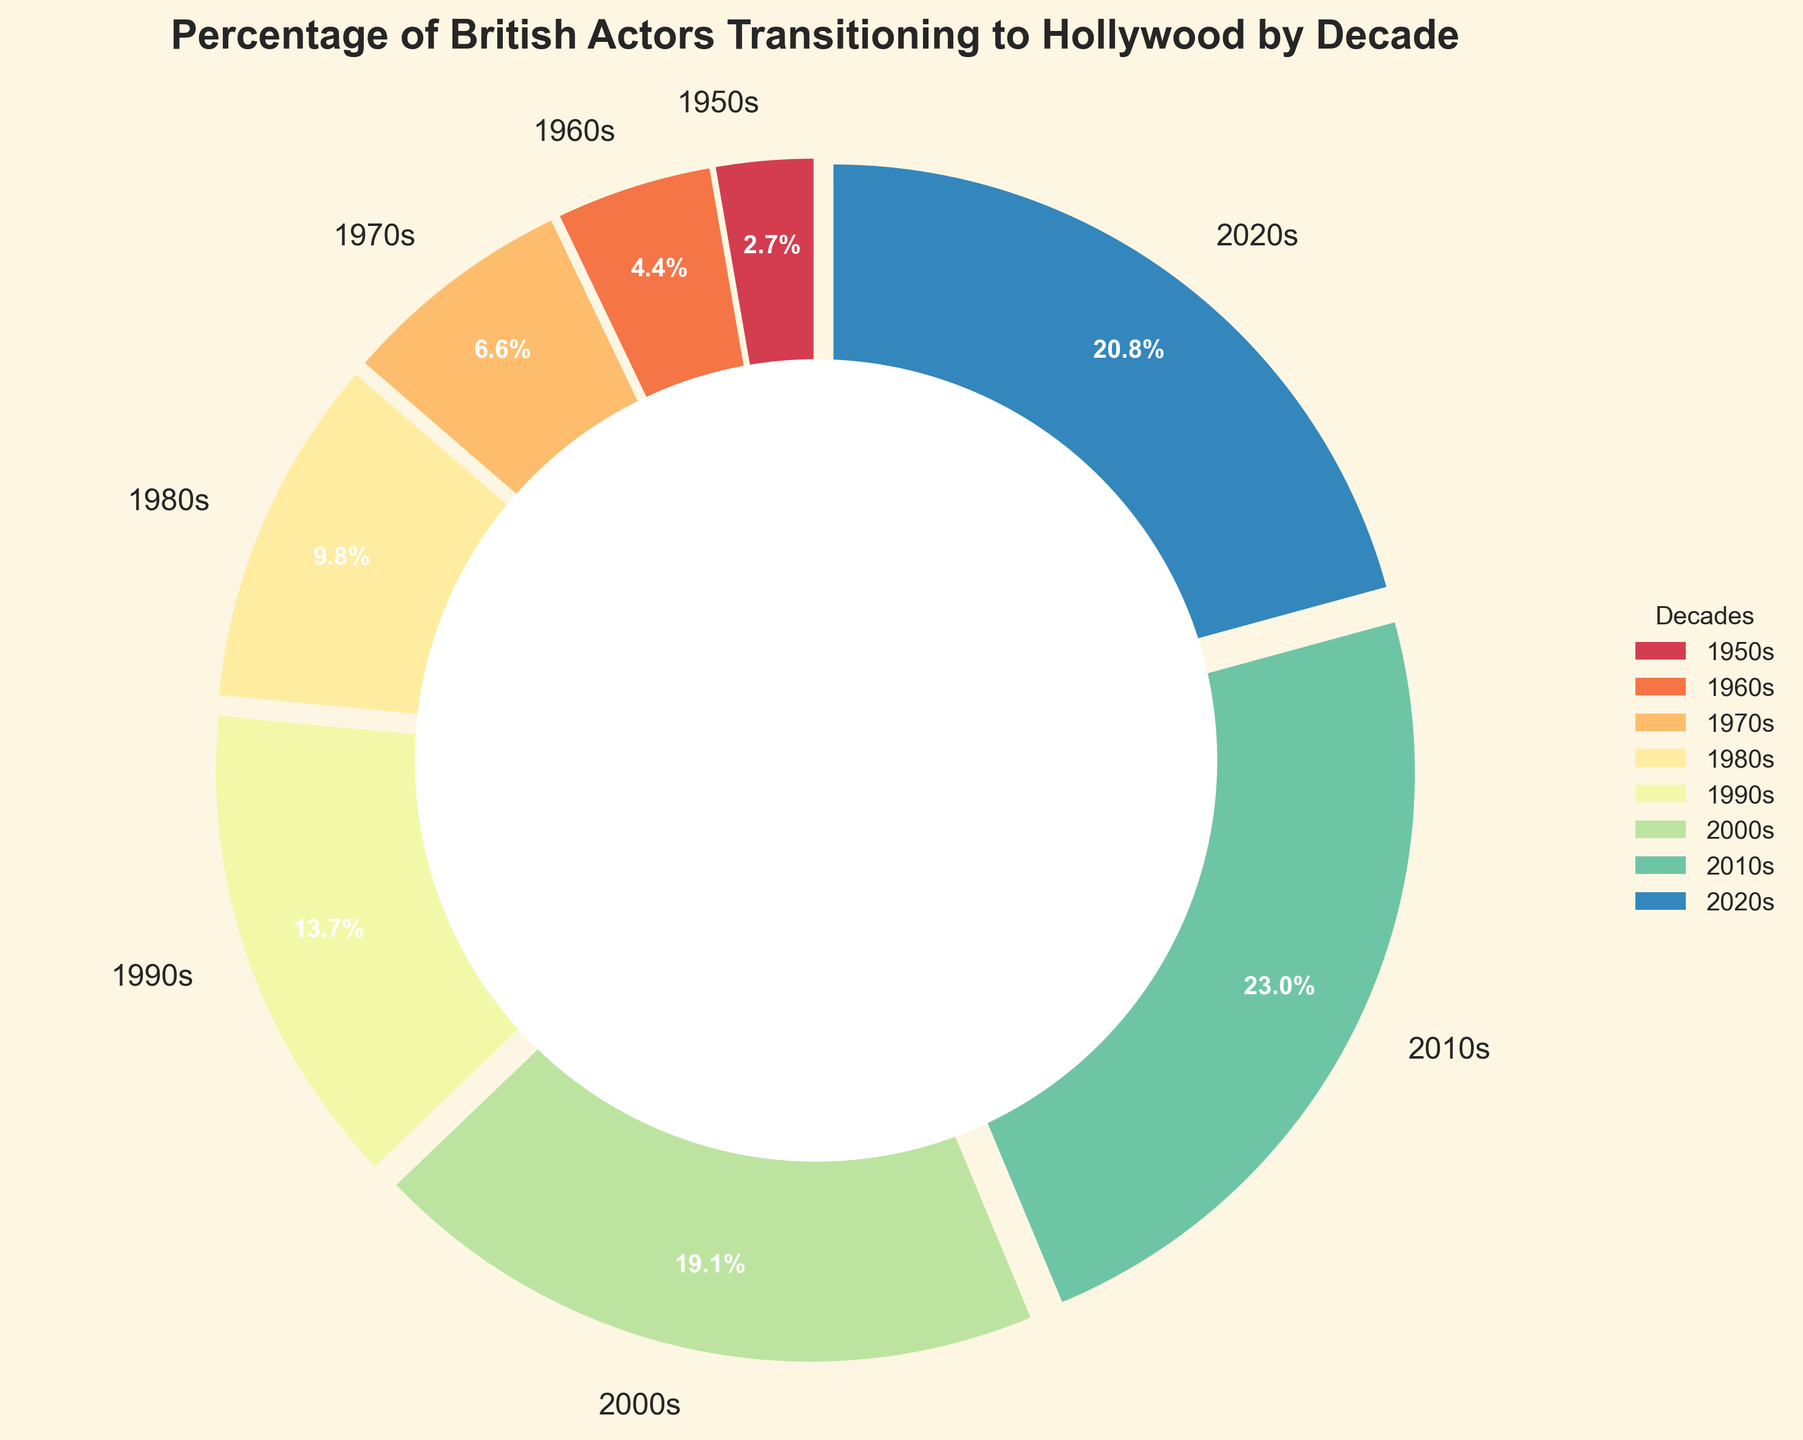What's the most recent decade where the percentage of British actors transitioning to Hollywood decreased? The chart shows the percentage for the 2010s as being 42%, while it drops to 38% in the 2020s. Thus, the most recent decade where the percentage decreased is the 2020s.
Answer: 2020s Which decade saw the highest increase in the percentage of British actors transitioning to Hollywood compared to the previous decade? Comparing decade-to-decade increases: 1950s to 1960s (3%), 1960s to 1970s (4%), 1970s to 1980s (6%), 1980s to 1990s (7%), 1990s to 2000s (10%), 2000s to 2010s (7%), and 2010s to 2020s (-4%). The highest increase occurred between the 1990s and 2000s with a 10% increase.
Answer: 1990s to 2000s What is the combined percentage for the 1950s and 1960s? From the pie chart, the percentages for the 1950s and 1960s are 5% and 8%, respectively. Adding these together gives 5% + 8% = 13%.
Answer: 13% Which decade had the smallest percentage of British actors transitioning to Hollywood? According to the chart, the 1950s had the smallest percentage at 5%.
Answer: 1950s How does the percentage in the 2010s compare to the 1980s? The chart shows that the 2010s had 42% while the 1980s had 18%. Therefore, the 2010s had a greater percentage than the 1980s.
Answer: 2010s > 1980s What is the average percentage across all decades shown? Adding the percentages for all the decades: 5% + 8% + 12% + 18% + 25% + 35% + 42% + 38% = 183%. There are 8 decades, so the average is 183% / 8 = 22.875%.
Answer: 22.875% What decade has the brightest segment in the pie chart? Based on the color scheme used, the most recent decades, such as the 2010s and 2020s, are typically assigned brighter colors in gradient maps. However, this might vary depending on your interpretation of 'bright'. If we consider 'bright' in this context, it would be the decade with notable colors, which look visually prominent. This should arguably be verified by viewing the chart.
Answer: 2010s or 2020s Which decades have percentages that are below 20%? The chart shows the 1950s (5%), 1960s (8%), 1970s (12%), and 1980s (18%) have percentages below 20%.
Answer: 1950s, 1960s, 1970s, 1980s 